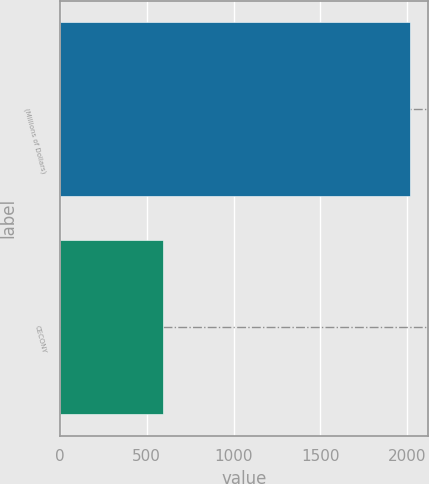Convert chart to OTSL. <chart><loc_0><loc_0><loc_500><loc_500><bar_chart><fcel>(Millions of Dollars)<fcel>CECONY<nl><fcel>2017<fcel>594<nl></chart> 